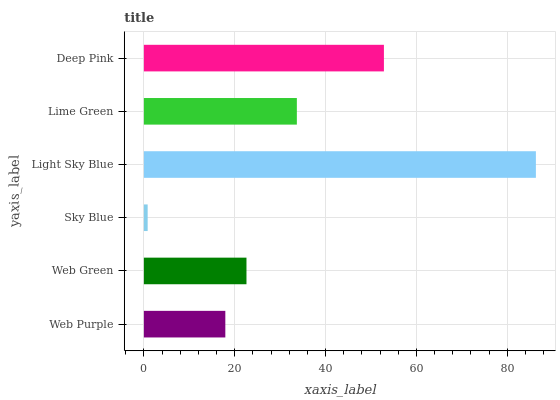Is Sky Blue the minimum?
Answer yes or no. Yes. Is Light Sky Blue the maximum?
Answer yes or no. Yes. Is Web Green the minimum?
Answer yes or no. No. Is Web Green the maximum?
Answer yes or no. No. Is Web Green greater than Web Purple?
Answer yes or no. Yes. Is Web Purple less than Web Green?
Answer yes or no. Yes. Is Web Purple greater than Web Green?
Answer yes or no. No. Is Web Green less than Web Purple?
Answer yes or no. No. Is Lime Green the high median?
Answer yes or no. Yes. Is Web Green the low median?
Answer yes or no. Yes. Is Web Purple the high median?
Answer yes or no. No. Is Sky Blue the low median?
Answer yes or no. No. 